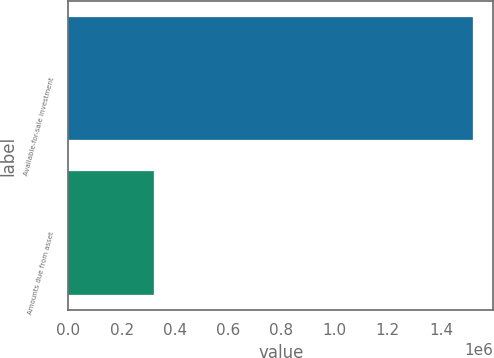Convert chart to OTSL. <chart><loc_0><loc_0><loc_500><loc_500><bar_chart><fcel>Available-for-sale investment<fcel>Amounts due from asset<nl><fcel>1.52055e+06<fcel>321316<nl></chart> 